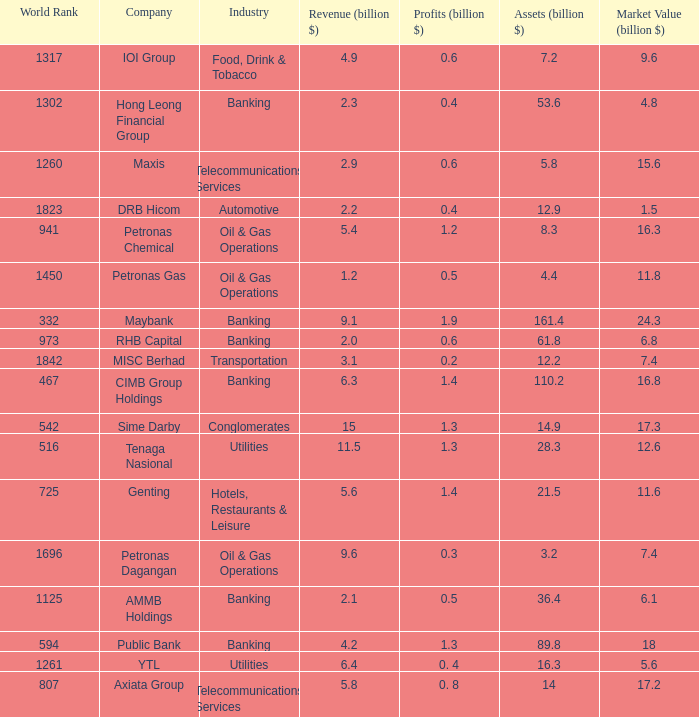Name the world rank for market value 17.2 807.0. 